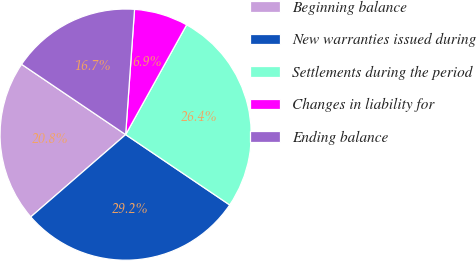Convert chart to OTSL. <chart><loc_0><loc_0><loc_500><loc_500><pie_chart><fcel>Beginning balance<fcel>New warranties issued during<fcel>Settlements during the period<fcel>Changes in liability for<fcel>Ending balance<nl><fcel>20.83%<fcel>29.17%<fcel>26.39%<fcel>6.94%<fcel>16.67%<nl></chart> 